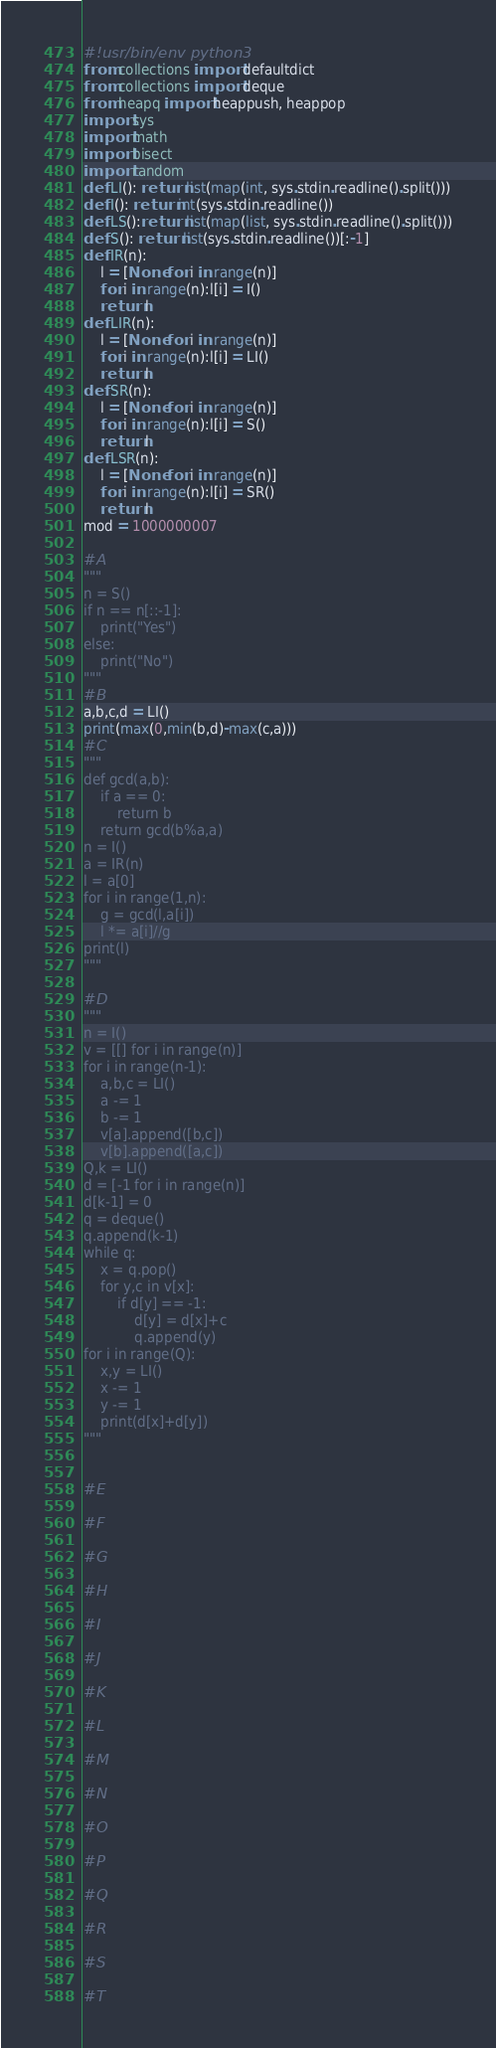Convert code to text. <code><loc_0><loc_0><loc_500><loc_500><_Python_>#!usr/bin/env python3
from collections import defaultdict
from collections import deque
from heapq import heappush, heappop
import sys
import math
import bisect
import random
def LI(): return list(map(int, sys.stdin.readline().split()))
def I(): return int(sys.stdin.readline())
def LS():return list(map(list, sys.stdin.readline().split()))
def S(): return list(sys.stdin.readline())[:-1]
def IR(n):
    l = [None for i in range(n)]
    for i in range(n):l[i] = I()
    return l
def LIR(n):
    l = [None for i in range(n)]
    for i in range(n):l[i] = LI()
    return l
def SR(n):
    l = [None for i in range(n)]
    for i in range(n):l[i] = S()
    return l
def LSR(n):
    l = [None for i in range(n)]
    for i in range(n):l[i] = SR()
    return l
mod = 1000000007

#A
"""
n = S()
if n == n[::-1]:
    print("Yes")
else:
    print("No")
"""
#B
a,b,c,d = LI()
print(max(0,min(b,d)-max(c,a)))
#C
"""
def gcd(a,b):
    if a == 0:
        return b
    return gcd(b%a,a)
n = I()
a = IR(n)
l = a[0]
for i in range(1,n):
    g = gcd(l,a[i])
    l *= a[i]//g
print(l)
"""

#D
"""
n = I()
v = [[] for i in range(n)]
for i in range(n-1):
    a,b,c = LI()
    a -= 1
    b -= 1
    v[a].append([b,c])
    v[b].append([a,c])
Q,k = LI()
d = [-1 for i in range(n)]
d[k-1] = 0
q = deque()
q.append(k-1)
while q:
    x = q.pop()
    for y,c in v[x]:
        if d[y] == -1:
            d[y] = d[x]+c
            q.append(y)
for i in range(Q):
    x,y = LI()
    x -= 1
    y -= 1
    print(d[x]+d[y])
"""


#E

#F

#G

#H

#I

#J

#K

#L

#M

#N

#O

#P

#Q

#R

#S

#T
</code> 